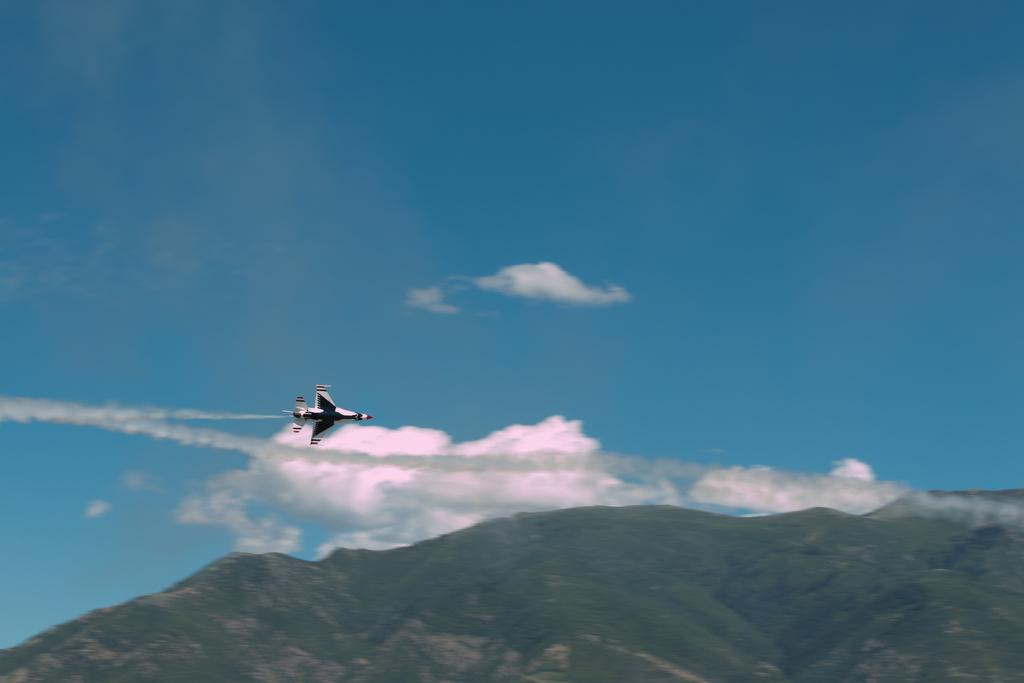What is the main subject of the image? The main subject of the image is an aeroplane. What is the aeroplane doing in the image? The aeroplane is flying in the sky. What type of landscape can be seen at the bottom of the image? There are hills at the bottom of the image. What is visible in the background of the image? The sky is visible in the background of the image. How many plates are stacked on the foot of the aeroplane in the image? There are no plates or feet of the aeroplane visible in the image; it is flying in the sky. 